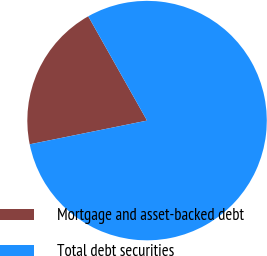Convert chart to OTSL. <chart><loc_0><loc_0><loc_500><loc_500><pie_chart><fcel>Mortgage and asset-backed debt<fcel>Total debt securities<nl><fcel>20.0%<fcel>80.0%<nl></chart> 